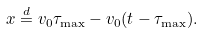Convert formula to latex. <formula><loc_0><loc_0><loc_500><loc_500>x \overset { d } { = } v _ { 0 } \tau _ { \max } - v _ { 0 } ( t - \tau _ { \max } ) .</formula> 